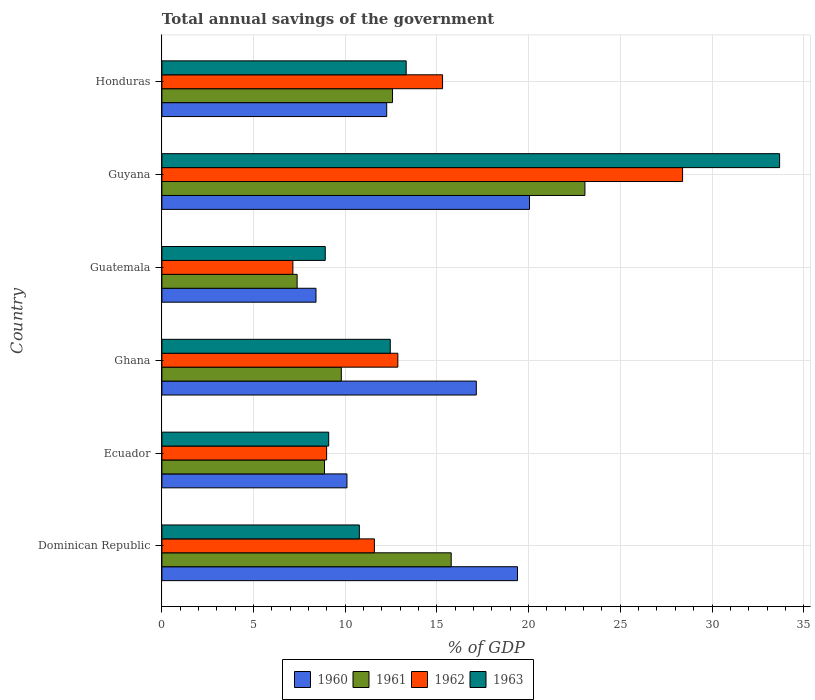Are the number of bars per tick equal to the number of legend labels?
Offer a very short reply. Yes. What is the label of the 3rd group of bars from the top?
Keep it short and to the point. Guatemala. In how many cases, is the number of bars for a given country not equal to the number of legend labels?
Provide a short and direct response. 0. What is the total annual savings of the government in 1962 in Guatemala?
Offer a very short reply. 7.14. Across all countries, what is the maximum total annual savings of the government in 1963?
Offer a very short reply. 33.69. Across all countries, what is the minimum total annual savings of the government in 1960?
Offer a very short reply. 8.4. In which country was the total annual savings of the government in 1962 maximum?
Provide a short and direct response. Guyana. In which country was the total annual savings of the government in 1962 minimum?
Keep it short and to the point. Guatemala. What is the total total annual savings of the government in 1961 in the graph?
Your answer should be very brief. 77.45. What is the difference between the total annual savings of the government in 1962 in Ecuador and that in Guatemala?
Your answer should be compact. 1.84. What is the difference between the total annual savings of the government in 1961 in Dominican Republic and the total annual savings of the government in 1960 in Ghana?
Your answer should be compact. -1.37. What is the average total annual savings of the government in 1962 per country?
Provide a succinct answer. 14.05. What is the difference between the total annual savings of the government in 1961 and total annual savings of the government in 1960 in Guyana?
Keep it short and to the point. 3.02. What is the ratio of the total annual savings of the government in 1961 in Ecuador to that in Guatemala?
Your answer should be compact. 1.2. Is the difference between the total annual savings of the government in 1961 in Ghana and Honduras greater than the difference between the total annual savings of the government in 1960 in Ghana and Honduras?
Offer a very short reply. No. What is the difference between the highest and the second highest total annual savings of the government in 1963?
Make the answer very short. 20.36. What is the difference between the highest and the lowest total annual savings of the government in 1961?
Offer a terse response. 15.7. What does the 3rd bar from the bottom in Dominican Republic represents?
Provide a short and direct response. 1962. Does the graph contain any zero values?
Keep it short and to the point. No. Where does the legend appear in the graph?
Keep it short and to the point. Bottom center. How are the legend labels stacked?
Give a very brief answer. Horizontal. What is the title of the graph?
Give a very brief answer. Total annual savings of the government. Does "2005" appear as one of the legend labels in the graph?
Your answer should be very brief. No. What is the label or title of the X-axis?
Make the answer very short. % of GDP. What is the label or title of the Y-axis?
Your answer should be very brief. Country. What is the % of GDP of 1960 in Dominican Republic?
Your answer should be very brief. 19.39. What is the % of GDP of 1961 in Dominican Republic?
Make the answer very short. 15.78. What is the % of GDP of 1962 in Dominican Republic?
Your answer should be very brief. 11.59. What is the % of GDP of 1963 in Dominican Republic?
Offer a very short reply. 10.77. What is the % of GDP in 1960 in Ecuador?
Provide a short and direct response. 10.09. What is the % of GDP of 1961 in Ecuador?
Provide a succinct answer. 8.87. What is the % of GDP of 1962 in Ecuador?
Offer a very short reply. 8.98. What is the % of GDP of 1963 in Ecuador?
Offer a very short reply. 9.1. What is the % of GDP of 1960 in Ghana?
Make the answer very short. 17.15. What is the % of GDP in 1961 in Ghana?
Ensure brevity in your answer.  9.78. What is the % of GDP of 1962 in Ghana?
Your answer should be very brief. 12.87. What is the % of GDP in 1963 in Ghana?
Your answer should be very brief. 12.45. What is the % of GDP of 1960 in Guatemala?
Your response must be concise. 8.4. What is the % of GDP in 1961 in Guatemala?
Give a very brief answer. 7.37. What is the % of GDP of 1962 in Guatemala?
Your response must be concise. 7.14. What is the % of GDP of 1963 in Guatemala?
Your response must be concise. 8.91. What is the % of GDP of 1960 in Guyana?
Your answer should be compact. 20.05. What is the % of GDP in 1961 in Guyana?
Your answer should be compact. 23.07. What is the % of GDP of 1962 in Guyana?
Provide a succinct answer. 28.4. What is the % of GDP in 1963 in Guyana?
Ensure brevity in your answer.  33.69. What is the % of GDP in 1960 in Honduras?
Offer a terse response. 12.26. What is the % of GDP in 1961 in Honduras?
Ensure brevity in your answer.  12.58. What is the % of GDP in 1962 in Honduras?
Offer a terse response. 15.31. What is the % of GDP in 1963 in Honduras?
Your answer should be very brief. 13.32. Across all countries, what is the maximum % of GDP in 1960?
Give a very brief answer. 20.05. Across all countries, what is the maximum % of GDP in 1961?
Your response must be concise. 23.07. Across all countries, what is the maximum % of GDP of 1962?
Keep it short and to the point. 28.4. Across all countries, what is the maximum % of GDP in 1963?
Your answer should be very brief. 33.69. Across all countries, what is the minimum % of GDP of 1960?
Your response must be concise. 8.4. Across all countries, what is the minimum % of GDP in 1961?
Provide a succinct answer. 7.37. Across all countries, what is the minimum % of GDP of 1962?
Provide a short and direct response. 7.14. Across all countries, what is the minimum % of GDP of 1963?
Provide a short and direct response. 8.91. What is the total % of GDP of 1960 in the graph?
Ensure brevity in your answer.  87.34. What is the total % of GDP of 1961 in the graph?
Ensure brevity in your answer.  77.45. What is the total % of GDP in 1962 in the graph?
Offer a terse response. 84.29. What is the total % of GDP of 1963 in the graph?
Provide a succinct answer. 88.24. What is the difference between the % of GDP of 1960 in Dominican Republic and that in Ecuador?
Ensure brevity in your answer.  9.3. What is the difference between the % of GDP of 1961 in Dominican Republic and that in Ecuador?
Ensure brevity in your answer.  6.91. What is the difference between the % of GDP of 1962 in Dominican Republic and that in Ecuador?
Provide a short and direct response. 2.61. What is the difference between the % of GDP of 1963 in Dominican Republic and that in Ecuador?
Offer a very short reply. 1.67. What is the difference between the % of GDP in 1960 in Dominican Republic and that in Ghana?
Provide a short and direct response. 2.25. What is the difference between the % of GDP in 1961 in Dominican Republic and that in Ghana?
Ensure brevity in your answer.  5.99. What is the difference between the % of GDP of 1962 in Dominican Republic and that in Ghana?
Give a very brief answer. -1.28. What is the difference between the % of GDP of 1963 in Dominican Republic and that in Ghana?
Give a very brief answer. -1.69. What is the difference between the % of GDP in 1960 in Dominican Republic and that in Guatemala?
Offer a very short reply. 10.99. What is the difference between the % of GDP of 1961 in Dominican Republic and that in Guatemala?
Provide a succinct answer. 8.4. What is the difference between the % of GDP of 1962 in Dominican Republic and that in Guatemala?
Offer a very short reply. 4.44. What is the difference between the % of GDP of 1963 in Dominican Republic and that in Guatemala?
Your response must be concise. 1.86. What is the difference between the % of GDP of 1960 in Dominican Republic and that in Guyana?
Offer a terse response. -0.65. What is the difference between the % of GDP of 1961 in Dominican Republic and that in Guyana?
Offer a very short reply. -7.29. What is the difference between the % of GDP in 1962 in Dominican Republic and that in Guyana?
Provide a short and direct response. -16.81. What is the difference between the % of GDP in 1963 in Dominican Republic and that in Guyana?
Give a very brief answer. -22.92. What is the difference between the % of GDP of 1960 in Dominican Republic and that in Honduras?
Provide a short and direct response. 7.13. What is the difference between the % of GDP of 1961 in Dominican Republic and that in Honduras?
Your answer should be compact. 3.2. What is the difference between the % of GDP of 1962 in Dominican Republic and that in Honduras?
Your answer should be very brief. -3.72. What is the difference between the % of GDP of 1963 in Dominican Republic and that in Honduras?
Your answer should be very brief. -2.56. What is the difference between the % of GDP of 1960 in Ecuador and that in Ghana?
Offer a terse response. -7.05. What is the difference between the % of GDP of 1961 in Ecuador and that in Ghana?
Your answer should be very brief. -0.92. What is the difference between the % of GDP of 1962 in Ecuador and that in Ghana?
Offer a terse response. -3.88. What is the difference between the % of GDP of 1963 in Ecuador and that in Ghana?
Provide a succinct answer. -3.36. What is the difference between the % of GDP in 1960 in Ecuador and that in Guatemala?
Your answer should be very brief. 1.69. What is the difference between the % of GDP of 1961 in Ecuador and that in Guatemala?
Offer a very short reply. 1.49. What is the difference between the % of GDP in 1962 in Ecuador and that in Guatemala?
Provide a short and direct response. 1.84. What is the difference between the % of GDP in 1963 in Ecuador and that in Guatemala?
Make the answer very short. 0.19. What is the difference between the % of GDP of 1960 in Ecuador and that in Guyana?
Ensure brevity in your answer.  -9.96. What is the difference between the % of GDP of 1961 in Ecuador and that in Guyana?
Provide a succinct answer. -14.2. What is the difference between the % of GDP of 1962 in Ecuador and that in Guyana?
Provide a short and direct response. -19.41. What is the difference between the % of GDP in 1963 in Ecuador and that in Guyana?
Your answer should be compact. -24.59. What is the difference between the % of GDP of 1960 in Ecuador and that in Honduras?
Make the answer very short. -2.17. What is the difference between the % of GDP of 1961 in Ecuador and that in Honduras?
Offer a very short reply. -3.71. What is the difference between the % of GDP in 1962 in Ecuador and that in Honduras?
Provide a succinct answer. -6.32. What is the difference between the % of GDP of 1963 in Ecuador and that in Honduras?
Provide a succinct answer. -4.23. What is the difference between the % of GDP in 1960 in Ghana and that in Guatemala?
Provide a short and direct response. 8.74. What is the difference between the % of GDP of 1961 in Ghana and that in Guatemala?
Ensure brevity in your answer.  2.41. What is the difference between the % of GDP in 1962 in Ghana and that in Guatemala?
Make the answer very short. 5.72. What is the difference between the % of GDP in 1963 in Ghana and that in Guatemala?
Provide a succinct answer. 3.55. What is the difference between the % of GDP in 1960 in Ghana and that in Guyana?
Provide a succinct answer. -2.9. What is the difference between the % of GDP in 1961 in Ghana and that in Guyana?
Provide a short and direct response. -13.28. What is the difference between the % of GDP of 1962 in Ghana and that in Guyana?
Keep it short and to the point. -15.53. What is the difference between the % of GDP of 1963 in Ghana and that in Guyana?
Ensure brevity in your answer.  -21.23. What is the difference between the % of GDP of 1960 in Ghana and that in Honduras?
Your response must be concise. 4.89. What is the difference between the % of GDP in 1961 in Ghana and that in Honduras?
Ensure brevity in your answer.  -2.79. What is the difference between the % of GDP of 1962 in Ghana and that in Honduras?
Offer a terse response. -2.44. What is the difference between the % of GDP of 1963 in Ghana and that in Honduras?
Provide a short and direct response. -0.87. What is the difference between the % of GDP in 1960 in Guatemala and that in Guyana?
Your answer should be compact. -11.64. What is the difference between the % of GDP in 1961 in Guatemala and that in Guyana?
Your answer should be compact. -15.7. What is the difference between the % of GDP in 1962 in Guatemala and that in Guyana?
Provide a succinct answer. -21.25. What is the difference between the % of GDP of 1963 in Guatemala and that in Guyana?
Ensure brevity in your answer.  -24.78. What is the difference between the % of GDP of 1960 in Guatemala and that in Honduras?
Offer a very short reply. -3.86. What is the difference between the % of GDP in 1961 in Guatemala and that in Honduras?
Provide a short and direct response. -5.2. What is the difference between the % of GDP of 1962 in Guatemala and that in Honduras?
Provide a succinct answer. -8.16. What is the difference between the % of GDP of 1963 in Guatemala and that in Honduras?
Your response must be concise. -4.41. What is the difference between the % of GDP of 1960 in Guyana and that in Honduras?
Provide a short and direct response. 7.79. What is the difference between the % of GDP of 1961 in Guyana and that in Honduras?
Keep it short and to the point. 10.49. What is the difference between the % of GDP in 1962 in Guyana and that in Honduras?
Ensure brevity in your answer.  13.09. What is the difference between the % of GDP of 1963 in Guyana and that in Honduras?
Your answer should be compact. 20.36. What is the difference between the % of GDP of 1960 in Dominican Republic and the % of GDP of 1961 in Ecuador?
Provide a succinct answer. 10.53. What is the difference between the % of GDP of 1960 in Dominican Republic and the % of GDP of 1962 in Ecuador?
Provide a short and direct response. 10.41. What is the difference between the % of GDP in 1960 in Dominican Republic and the % of GDP in 1963 in Ecuador?
Make the answer very short. 10.3. What is the difference between the % of GDP of 1961 in Dominican Republic and the % of GDP of 1962 in Ecuador?
Your answer should be very brief. 6.79. What is the difference between the % of GDP of 1961 in Dominican Republic and the % of GDP of 1963 in Ecuador?
Offer a terse response. 6.68. What is the difference between the % of GDP of 1962 in Dominican Republic and the % of GDP of 1963 in Ecuador?
Provide a short and direct response. 2.49. What is the difference between the % of GDP of 1960 in Dominican Republic and the % of GDP of 1961 in Ghana?
Provide a succinct answer. 9.61. What is the difference between the % of GDP in 1960 in Dominican Republic and the % of GDP in 1962 in Ghana?
Your answer should be very brief. 6.53. What is the difference between the % of GDP of 1960 in Dominican Republic and the % of GDP of 1963 in Ghana?
Provide a succinct answer. 6.94. What is the difference between the % of GDP of 1961 in Dominican Republic and the % of GDP of 1962 in Ghana?
Your answer should be compact. 2.91. What is the difference between the % of GDP of 1961 in Dominican Republic and the % of GDP of 1963 in Ghana?
Your answer should be very brief. 3.32. What is the difference between the % of GDP of 1962 in Dominican Republic and the % of GDP of 1963 in Ghana?
Your response must be concise. -0.87. What is the difference between the % of GDP of 1960 in Dominican Republic and the % of GDP of 1961 in Guatemala?
Give a very brief answer. 12.02. What is the difference between the % of GDP in 1960 in Dominican Republic and the % of GDP in 1962 in Guatemala?
Offer a terse response. 12.25. What is the difference between the % of GDP of 1960 in Dominican Republic and the % of GDP of 1963 in Guatemala?
Give a very brief answer. 10.48. What is the difference between the % of GDP in 1961 in Dominican Republic and the % of GDP in 1962 in Guatemala?
Provide a succinct answer. 8.63. What is the difference between the % of GDP in 1961 in Dominican Republic and the % of GDP in 1963 in Guatemala?
Offer a very short reply. 6.87. What is the difference between the % of GDP in 1962 in Dominican Republic and the % of GDP in 1963 in Guatemala?
Keep it short and to the point. 2.68. What is the difference between the % of GDP in 1960 in Dominican Republic and the % of GDP in 1961 in Guyana?
Your answer should be very brief. -3.68. What is the difference between the % of GDP in 1960 in Dominican Republic and the % of GDP in 1962 in Guyana?
Provide a short and direct response. -9. What is the difference between the % of GDP of 1960 in Dominican Republic and the % of GDP of 1963 in Guyana?
Ensure brevity in your answer.  -14.29. What is the difference between the % of GDP of 1961 in Dominican Republic and the % of GDP of 1962 in Guyana?
Ensure brevity in your answer.  -12.62. What is the difference between the % of GDP of 1961 in Dominican Republic and the % of GDP of 1963 in Guyana?
Provide a short and direct response. -17.91. What is the difference between the % of GDP of 1962 in Dominican Republic and the % of GDP of 1963 in Guyana?
Offer a very short reply. -22.1. What is the difference between the % of GDP of 1960 in Dominican Republic and the % of GDP of 1961 in Honduras?
Ensure brevity in your answer.  6.82. What is the difference between the % of GDP of 1960 in Dominican Republic and the % of GDP of 1962 in Honduras?
Provide a succinct answer. 4.09. What is the difference between the % of GDP in 1960 in Dominican Republic and the % of GDP in 1963 in Honduras?
Ensure brevity in your answer.  6.07. What is the difference between the % of GDP of 1961 in Dominican Republic and the % of GDP of 1962 in Honduras?
Provide a succinct answer. 0.47. What is the difference between the % of GDP of 1961 in Dominican Republic and the % of GDP of 1963 in Honduras?
Provide a short and direct response. 2.45. What is the difference between the % of GDP in 1962 in Dominican Republic and the % of GDP in 1963 in Honduras?
Your answer should be compact. -1.73. What is the difference between the % of GDP of 1960 in Ecuador and the % of GDP of 1961 in Ghana?
Provide a short and direct response. 0.31. What is the difference between the % of GDP of 1960 in Ecuador and the % of GDP of 1962 in Ghana?
Your response must be concise. -2.77. What is the difference between the % of GDP of 1960 in Ecuador and the % of GDP of 1963 in Ghana?
Offer a terse response. -2.36. What is the difference between the % of GDP in 1961 in Ecuador and the % of GDP in 1962 in Ghana?
Keep it short and to the point. -4. What is the difference between the % of GDP of 1961 in Ecuador and the % of GDP of 1963 in Ghana?
Ensure brevity in your answer.  -3.59. What is the difference between the % of GDP of 1962 in Ecuador and the % of GDP of 1963 in Ghana?
Keep it short and to the point. -3.47. What is the difference between the % of GDP of 1960 in Ecuador and the % of GDP of 1961 in Guatemala?
Your response must be concise. 2.72. What is the difference between the % of GDP in 1960 in Ecuador and the % of GDP in 1962 in Guatemala?
Keep it short and to the point. 2.95. What is the difference between the % of GDP of 1960 in Ecuador and the % of GDP of 1963 in Guatemala?
Offer a very short reply. 1.18. What is the difference between the % of GDP in 1961 in Ecuador and the % of GDP in 1962 in Guatemala?
Offer a terse response. 1.72. What is the difference between the % of GDP in 1961 in Ecuador and the % of GDP in 1963 in Guatemala?
Ensure brevity in your answer.  -0.04. What is the difference between the % of GDP in 1962 in Ecuador and the % of GDP in 1963 in Guatemala?
Provide a succinct answer. 0.07. What is the difference between the % of GDP in 1960 in Ecuador and the % of GDP in 1961 in Guyana?
Offer a very short reply. -12.98. What is the difference between the % of GDP of 1960 in Ecuador and the % of GDP of 1962 in Guyana?
Give a very brief answer. -18.3. What is the difference between the % of GDP of 1960 in Ecuador and the % of GDP of 1963 in Guyana?
Make the answer very short. -23.59. What is the difference between the % of GDP of 1961 in Ecuador and the % of GDP of 1962 in Guyana?
Offer a very short reply. -19.53. What is the difference between the % of GDP in 1961 in Ecuador and the % of GDP in 1963 in Guyana?
Ensure brevity in your answer.  -24.82. What is the difference between the % of GDP of 1962 in Ecuador and the % of GDP of 1963 in Guyana?
Your answer should be very brief. -24.7. What is the difference between the % of GDP in 1960 in Ecuador and the % of GDP in 1961 in Honduras?
Keep it short and to the point. -2.48. What is the difference between the % of GDP in 1960 in Ecuador and the % of GDP in 1962 in Honduras?
Give a very brief answer. -5.21. What is the difference between the % of GDP in 1960 in Ecuador and the % of GDP in 1963 in Honduras?
Provide a short and direct response. -3.23. What is the difference between the % of GDP of 1961 in Ecuador and the % of GDP of 1962 in Honduras?
Ensure brevity in your answer.  -6.44. What is the difference between the % of GDP of 1961 in Ecuador and the % of GDP of 1963 in Honduras?
Keep it short and to the point. -4.45. What is the difference between the % of GDP in 1962 in Ecuador and the % of GDP in 1963 in Honduras?
Make the answer very short. -4.34. What is the difference between the % of GDP of 1960 in Ghana and the % of GDP of 1961 in Guatemala?
Give a very brief answer. 9.77. What is the difference between the % of GDP of 1960 in Ghana and the % of GDP of 1962 in Guatemala?
Offer a very short reply. 10. What is the difference between the % of GDP of 1960 in Ghana and the % of GDP of 1963 in Guatemala?
Your answer should be very brief. 8.24. What is the difference between the % of GDP in 1961 in Ghana and the % of GDP in 1962 in Guatemala?
Provide a short and direct response. 2.64. What is the difference between the % of GDP of 1961 in Ghana and the % of GDP of 1963 in Guatemala?
Ensure brevity in your answer.  0.88. What is the difference between the % of GDP of 1962 in Ghana and the % of GDP of 1963 in Guatemala?
Keep it short and to the point. 3.96. What is the difference between the % of GDP in 1960 in Ghana and the % of GDP in 1961 in Guyana?
Offer a terse response. -5.92. What is the difference between the % of GDP in 1960 in Ghana and the % of GDP in 1962 in Guyana?
Offer a terse response. -11.25. What is the difference between the % of GDP of 1960 in Ghana and the % of GDP of 1963 in Guyana?
Your answer should be compact. -16.54. What is the difference between the % of GDP of 1961 in Ghana and the % of GDP of 1962 in Guyana?
Offer a very short reply. -18.61. What is the difference between the % of GDP of 1961 in Ghana and the % of GDP of 1963 in Guyana?
Your response must be concise. -23.9. What is the difference between the % of GDP in 1962 in Ghana and the % of GDP in 1963 in Guyana?
Keep it short and to the point. -20.82. What is the difference between the % of GDP of 1960 in Ghana and the % of GDP of 1961 in Honduras?
Make the answer very short. 4.57. What is the difference between the % of GDP in 1960 in Ghana and the % of GDP in 1962 in Honduras?
Your answer should be compact. 1.84. What is the difference between the % of GDP of 1960 in Ghana and the % of GDP of 1963 in Honduras?
Your response must be concise. 3.82. What is the difference between the % of GDP of 1961 in Ghana and the % of GDP of 1962 in Honduras?
Provide a succinct answer. -5.52. What is the difference between the % of GDP in 1961 in Ghana and the % of GDP in 1963 in Honduras?
Provide a succinct answer. -3.54. What is the difference between the % of GDP of 1962 in Ghana and the % of GDP of 1963 in Honduras?
Offer a very short reply. -0.46. What is the difference between the % of GDP of 1960 in Guatemala and the % of GDP of 1961 in Guyana?
Give a very brief answer. -14.67. What is the difference between the % of GDP in 1960 in Guatemala and the % of GDP in 1962 in Guyana?
Your answer should be very brief. -19.99. What is the difference between the % of GDP of 1960 in Guatemala and the % of GDP of 1963 in Guyana?
Ensure brevity in your answer.  -25.28. What is the difference between the % of GDP in 1961 in Guatemala and the % of GDP in 1962 in Guyana?
Offer a very short reply. -21.02. What is the difference between the % of GDP in 1961 in Guatemala and the % of GDP in 1963 in Guyana?
Give a very brief answer. -26.31. What is the difference between the % of GDP of 1962 in Guatemala and the % of GDP of 1963 in Guyana?
Your answer should be very brief. -26.54. What is the difference between the % of GDP in 1960 in Guatemala and the % of GDP in 1961 in Honduras?
Ensure brevity in your answer.  -4.17. What is the difference between the % of GDP of 1960 in Guatemala and the % of GDP of 1962 in Honduras?
Make the answer very short. -6.9. What is the difference between the % of GDP in 1960 in Guatemala and the % of GDP in 1963 in Honduras?
Offer a very short reply. -4.92. What is the difference between the % of GDP of 1961 in Guatemala and the % of GDP of 1962 in Honduras?
Provide a succinct answer. -7.93. What is the difference between the % of GDP of 1961 in Guatemala and the % of GDP of 1963 in Honduras?
Offer a very short reply. -5.95. What is the difference between the % of GDP of 1962 in Guatemala and the % of GDP of 1963 in Honduras?
Offer a terse response. -6.18. What is the difference between the % of GDP in 1960 in Guyana and the % of GDP in 1961 in Honduras?
Offer a terse response. 7.47. What is the difference between the % of GDP in 1960 in Guyana and the % of GDP in 1962 in Honduras?
Make the answer very short. 4.74. What is the difference between the % of GDP in 1960 in Guyana and the % of GDP in 1963 in Honduras?
Offer a very short reply. 6.73. What is the difference between the % of GDP of 1961 in Guyana and the % of GDP of 1962 in Honduras?
Provide a short and direct response. 7.76. What is the difference between the % of GDP of 1961 in Guyana and the % of GDP of 1963 in Honduras?
Provide a succinct answer. 9.75. What is the difference between the % of GDP in 1962 in Guyana and the % of GDP in 1963 in Honduras?
Your answer should be compact. 15.07. What is the average % of GDP in 1960 per country?
Your response must be concise. 14.56. What is the average % of GDP of 1961 per country?
Your response must be concise. 12.91. What is the average % of GDP of 1962 per country?
Offer a terse response. 14.05. What is the average % of GDP of 1963 per country?
Offer a terse response. 14.71. What is the difference between the % of GDP in 1960 and % of GDP in 1961 in Dominican Republic?
Offer a very short reply. 3.62. What is the difference between the % of GDP in 1960 and % of GDP in 1962 in Dominican Republic?
Provide a succinct answer. 7.8. What is the difference between the % of GDP of 1960 and % of GDP of 1963 in Dominican Republic?
Your answer should be very brief. 8.63. What is the difference between the % of GDP of 1961 and % of GDP of 1962 in Dominican Republic?
Make the answer very short. 4.19. What is the difference between the % of GDP in 1961 and % of GDP in 1963 in Dominican Republic?
Keep it short and to the point. 5.01. What is the difference between the % of GDP in 1962 and % of GDP in 1963 in Dominican Republic?
Provide a succinct answer. 0.82. What is the difference between the % of GDP in 1960 and % of GDP in 1961 in Ecuador?
Your response must be concise. 1.22. What is the difference between the % of GDP in 1960 and % of GDP in 1962 in Ecuador?
Make the answer very short. 1.11. What is the difference between the % of GDP of 1960 and % of GDP of 1963 in Ecuador?
Provide a succinct answer. 1. What is the difference between the % of GDP of 1961 and % of GDP of 1962 in Ecuador?
Offer a very short reply. -0.12. What is the difference between the % of GDP in 1961 and % of GDP in 1963 in Ecuador?
Offer a terse response. -0.23. What is the difference between the % of GDP of 1962 and % of GDP of 1963 in Ecuador?
Provide a short and direct response. -0.11. What is the difference between the % of GDP of 1960 and % of GDP of 1961 in Ghana?
Your response must be concise. 7.36. What is the difference between the % of GDP of 1960 and % of GDP of 1962 in Ghana?
Provide a short and direct response. 4.28. What is the difference between the % of GDP of 1960 and % of GDP of 1963 in Ghana?
Your response must be concise. 4.69. What is the difference between the % of GDP in 1961 and % of GDP in 1962 in Ghana?
Provide a short and direct response. -3.08. What is the difference between the % of GDP of 1961 and % of GDP of 1963 in Ghana?
Keep it short and to the point. -2.67. What is the difference between the % of GDP in 1962 and % of GDP in 1963 in Ghana?
Your answer should be compact. 0.41. What is the difference between the % of GDP in 1960 and % of GDP in 1961 in Guatemala?
Make the answer very short. 1.03. What is the difference between the % of GDP in 1960 and % of GDP in 1962 in Guatemala?
Give a very brief answer. 1.26. What is the difference between the % of GDP in 1960 and % of GDP in 1963 in Guatemala?
Your answer should be compact. -0.51. What is the difference between the % of GDP in 1961 and % of GDP in 1962 in Guatemala?
Provide a short and direct response. 0.23. What is the difference between the % of GDP of 1961 and % of GDP of 1963 in Guatemala?
Your answer should be compact. -1.53. What is the difference between the % of GDP in 1962 and % of GDP in 1963 in Guatemala?
Your answer should be compact. -1.76. What is the difference between the % of GDP in 1960 and % of GDP in 1961 in Guyana?
Offer a terse response. -3.02. What is the difference between the % of GDP in 1960 and % of GDP in 1962 in Guyana?
Make the answer very short. -8.35. What is the difference between the % of GDP in 1960 and % of GDP in 1963 in Guyana?
Provide a short and direct response. -13.64. What is the difference between the % of GDP in 1961 and % of GDP in 1962 in Guyana?
Your response must be concise. -5.33. What is the difference between the % of GDP in 1961 and % of GDP in 1963 in Guyana?
Keep it short and to the point. -10.62. What is the difference between the % of GDP of 1962 and % of GDP of 1963 in Guyana?
Make the answer very short. -5.29. What is the difference between the % of GDP in 1960 and % of GDP in 1961 in Honduras?
Give a very brief answer. -0.32. What is the difference between the % of GDP in 1960 and % of GDP in 1962 in Honduras?
Offer a very short reply. -3.05. What is the difference between the % of GDP in 1960 and % of GDP in 1963 in Honduras?
Ensure brevity in your answer.  -1.06. What is the difference between the % of GDP of 1961 and % of GDP of 1962 in Honduras?
Keep it short and to the point. -2.73. What is the difference between the % of GDP in 1961 and % of GDP in 1963 in Honduras?
Make the answer very short. -0.75. What is the difference between the % of GDP of 1962 and % of GDP of 1963 in Honduras?
Offer a terse response. 1.98. What is the ratio of the % of GDP of 1960 in Dominican Republic to that in Ecuador?
Offer a very short reply. 1.92. What is the ratio of the % of GDP of 1961 in Dominican Republic to that in Ecuador?
Make the answer very short. 1.78. What is the ratio of the % of GDP of 1962 in Dominican Republic to that in Ecuador?
Your answer should be compact. 1.29. What is the ratio of the % of GDP in 1963 in Dominican Republic to that in Ecuador?
Provide a succinct answer. 1.18. What is the ratio of the % of GDP in 1960 in Dominican Republic to that in Ghana?
Provide a short and direct response. 1.13. What is the ratio of the % of GDP of 1961 in Dominican Republic to that in Ghana?
Your answer should be very brief. 1.61. What is the ratio of the % of GDP in 1962 in Dominican Republic to that in Ghana?
Your answer should be very brief. 0.9. What is the ratio of the % of GDP of 1963 in Dominican Republic to that in Ghana?
Your response must be concise. 0.86. What is the ratio of the % of GDP in 1960 in Dominican Republic to that in Guatemala?
Provide a short and direct response. 2.31. What is the ratio of the % of GDP in 1961 in Dominican Republic to that in Guatemala?
Provide a succinct answer. 2.14. What is the ratio of the % of GDP in 1962 in Dominican Republic to that in Guatemala?
Your response must be concise. 1.62. What is the ratio of the % of GDP in 1963 in Dominican Republic to that in Guatemala?
Provide a succinct answer. 1.21. What is the ratio of the % of GDP of 1960 in Dominican Republic to that in Guyana?
Provide a succinct answer. 0.97. What is the ratio of the % of GDP in 1961 in Dominican Republic to that in Guyana?
Offer a terse response. 0.68. What is the ratio of the % of GDP of 1962 in Dominican Republic to that in Guyana?
Offer a terse response. 0.41. What is the ratio of the % of GDP in 1963 in Dominican Republic to that in Guyana?
Your answer should be very brief. 0.32. What is the ratio of the % of GDP in 1960 in Dominican Republic to that in Honduras?
Your response must be concise. 1.58. What is the ratio of the % of GDP of 1961 in Dominican Republic to that in Honduras?
Make the answer very short. 1.25. What is the ratio of the % of GDP of 1962 in Dominican Republic to that in Honduras?
Offer a terse response. 0.76. What is the ratio of the % of GDP in 1963 in Dominican Republic to that in Honduras?
Your response must be concise. 0.81. What is the ratio of the % of GDP of 1960 in Ecuador to that in Ghana?
Your response must be concise. 0.59. What is the ratio of the % of GDP in 1961 in Ecuador to that in Ghana?
Your answer should be very brief. 0.91. What is the ratio of the % of GDP in 1962 in Ecuador to that in Ghana?
Keep it short and to the point. 0.7. What is the ratio of the % of GDP in 1963 in Ecuador to that in Ghana?
Your answer should be very brief. 0.73. What is the ratio of the % of GDP in 1960 in Ecuador to that in Guatemala?
Your answer should be compact. 1.2. What is the ratio of the % of GDP in 1961 in Ecuador to that in Guatemala?
Offer a terse response. 1.2. What is the ratio of the % of GDP of 1962 in Ecuador to that in Guatemala?
Offer a very short reply. 1.26. What is the ratio of the % of GDP in 1963 in Ecuador to that in Guatemala?
Ensure brevity in your answer.  1.02. What is the ratio of the % of GDP in 1960 in Ecuador to that in Guyana?
Make the answer very short. 0.5. What is the ratio of the % of GDP in 1961 in Ecuador to that in Guyana?
Your response must be concise. 0.38. What is the ratio of the % of GDP of 1962 in Ecuador to that in Guyana?
Offer a very short reply. 0.32. What is the ratio of the % of GDP of 1963 in Ecuador to that in Guyana?
Your response must be concise. 0.27. What is the ratio of the % of GDP of 1960 in Ecuador to that in Honduras?
Keep it short and to the point. 0.82. What is the ratio of the % of GDP in 1961 in Ecuador to that in Honduras?
Offer a terse response. 0.71. What is the ratio of the % of GDP in 1962 in Ecuador to that in Honduras?
Provide a short and direct response. 0.59. What is the ratio of the % of GDP in 1963 in Ecuador to that in Honduras?
Your answer should be very brief. 0.68. What is the ratio of the % of GDP in 1960 in Ghana to that in Guatemala?
Make the answer very short. 2.04. What is the ratio of the % of GDP of 1961 in Ghana to that in Guatemala?
Provide a succinct answer. 1.33. What is the ratio of the % of GDP in 1962 in Ghana to that in Guatemala?
Keep it short and to the point. 1.8. What is the ratio of the % of GDP in 1963 in Ghana to that in Guatemala?
Ensure brevity in your answer.  1.4. What is the ratio of the % of GDP of 1960 in Ghana to that in Guyana?
Your response must be concise. 0.86. What is the ratio of the % of GDP of 1961 in Ghana to that in Guyana?
Keep it short and to the point. 0.42. What is the ratio of the % of GDP in 1962 in Ghana to that in Guyana?
Provide a short and direct response. 0.45. What is the ratio of the % of GDP of 1963 in Ghana to that in Guyana?
Your response must be concise. 0.37. What is the ratio of the % of GDP in 1960 in Ghana to that in Honduras?
Make the answer very short. 1.4. What is the ratio of the % of GDP of 1961 in Ghana to that in Honduras?
Offer a terse response. 0.78. What is the ratio of the % of GDP in 1962 in Ghana to that in Honduras?
Provide a short and direct response. 0.84. What is the ratio of the % of GDP in 1963 in Ghana to that in Honduras?
Your answer should be very brief. 0.93. What is the ratio of the % of GDP of 1960 in Guatemala to that in Guyana?
Provide a succinct answer. 0.42. What is the ratio of the % of GDP of 1961 in Guatemala to that in Guyana?
Offer a terse response. 0.32. What is the ratio of the % of GDP of 1962 in Guatemala to that in Guyana?
Provide a short and direct response. 0.25. What is the ratio of the % of GDP in 1963 in Guatemala to that in Guyana?
Offer a very short reply. 0.26. What is the ratio of the % of GDP of 1960 in Guatemala to that in Honduras?
Make the answer very short. 0.69. What is the ratio of the % of GDP in 1961 in Guatemala to that in Honduras?
Your answer should be very brief. 0.59. What is the ratio of the % of GDP of 1962 in Guatemala to that in Honduras?
Offer a very short reply. 0.47. What is the ratio of the % of GDP in 1963 in Guatemala to that in Honduras?
Your answer should be very brief. 0.67. What is the ratio of the % of GDP in 1960 in Guyana to that in Honduras?
Your answer should be compact. 1.64. What is the ratio of the % of GDP of 1961 in Guyana to that in Honduras?
Offer a very short reply. 1.83. What is the ratio of the % of GDP in 1962 in Guyana to that in Honduras?
Make the answer very short. 1.86. What is the ratio of the % of GDP in 1963 in Guyana to that in Honduras?
Offer a terse response. 2.53. What is the difference between the highest and the second highest % of GDP in 1960?
Give a very brief answer. 0.65. What is the difference between the highest and the second highest % of GDP of 1961?
Keep it short and to the point. 7.29. What is the difference between the highest and the second highest % of GDP in 1962?
Keep it short and to the point. 13.09. What is the difference between the highest and the second highest % of GDP of 1963?
Keep it short and to the point. 20.36. What is the difference between the highest and the lowest % of GDP of 1960?
Your response must be concise. 11.64. What is the difference between the highest and the lowest % of GDP of 1961?
Keep it short and to the point. 15.7. What is the difference between the highest and the lowest % of GDP in 1962?
Give a very brief answer. 21.25. What is the difference between the highest and the lowest % of GDP in 1963?
Provide a short and direct response. 24.78. 